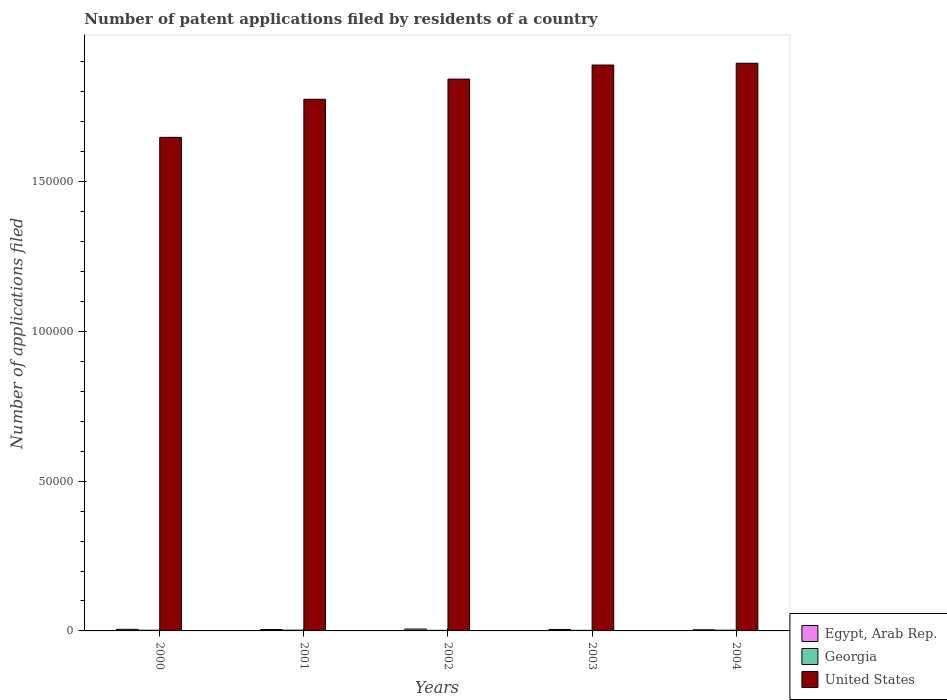How many different coloured bars are there?
Your answer should be very brief. 3. How many groups of bars are there?
Your answer should be very brief. 5. Are the number of bars on each tick of the X-axis equal?
Your answer should be very brief. Yes. What is the number of applications filed in Georgia in 2002?
Keep it short and to the point. 194. Across all years, what is the maximum number of applications filed in Georgia?
Offer a very short reply. 254. Across all years, what is the minimum number of applications filed in United States?
Keep it short and to the point. 1.65e+05. In which year was the number of applications filed in United States maximum?
Your answer should be very brief. 2004. In which year was the number of applications filed in Egypt, Arab Rep. minimum?
Provide a succinct answer. 2004. What is the total number of applications filed in United States in the graph?
Your answer should be compact. 9.05e+05. What is the difference between the number of applications filed in Egypt, Arab Rep. in 2003 and that in 2004?
Give a very brief answer. 111. What is the difference between the number of applications filed in Georgia in 2003 and the number of applications filed in Egypt, Arab Rep. in 2001?
Keep it short and to the point. -269. What is the average number of applications filed in United States per year?
Your response must be concise. 1.81e+05. In the year 2003, what is the difference between the number of applications filed in United States and number of applications filed in Georgia?
Offer a terse response. 1.89e+05. What is the ratio of the number of applications filed in Egypt, Arab Rep. in 2002 to that in 2004?
Keep it short and to the point. 1.64. Is the number of applications filed in Egypt, Arab Rep. in 2000 less than that in 2003?
Keep it short and to the point. No. What is the difference between the highest and the second highest number of applications filed in Egypt, Arab Rep.?
Your answer should be very brief. 93. What is the difference between the highest and the lowest number of applications filed in Egypt, Arab Rep.?
Your answer should be compact. 245. In how many years, is the number of applications filed in United States greater than the average number of applications filed in United States taken over all years?
Give a very brief answer. 3. What does the 3rd bar from the left in 2002 represents?
Your answer should be very brief. United States. Is it the case that in every year, the sum of the number of applications filed in Georgia and number of applications filed in United States is greater than the number of applications filed in Egypt, Arab Rep.?
Provide a succinct answer. Yes. Are all the bars in the graph horizontal?
Your answer should be compact. No. What is the difference between two consecutive major ticks on the Y-axis?
Keep it short and to the point. 5.00e+04. Are the values on the major ticks of Y-axis written in scientific E-notation?
Give a very brief answer. No. Where does the legend appear in the graph?
Keep it short and to the point. Bottom right. How many legend labels are there?
Make the answer very short. 3. What is the title of the graph?
Give a very brief answer. Number of patent applications filed by residents of a country. What is the label or title of the X-axis?
Offer a very short reply. Years. What is the label or title of the Y-axis?
Offer a terse response. Number of applications filed. What is the Number of applications filed in Egypt, Arab Rep. in 2000?
Give a very brief answer. 534. What is the Number of applications filed in Georgia in 2000?
Your answer should be compact. 232. What is the Number of applications filed in United States in 2000?
Your answer should be very brief. 1.65e+05. What is the Number of applications filed in Egypt, Arab Rep. in 2001?
Offer a very short reply. 464. What is the Number of applications filed in Georgia in 2001?
Give a very brief answer. 254. What is the Number of applications filed in United States in 2001?
Offer a terse response. 1.78e+05. What is the Number of applications filed of Egypt, Arab Rep. in 2002?
Your response must be concise. 627. What is the Number of applications filed in Georgia in 2002?
Your answer should be very brief. 194. What is the Number of applications filed in United States in 2002?
Your answer should be compact. 1.84e+05. What is the Number of applications filed of Egypt, Arab Rep. in 2003?
Keep it short and to the point. 493. What is the Number of applications filed of Georgia in 2003?
Give a very brief answer. 195. What is the Number of applications filed of United States in 2003?
Provide a succinct answer. 1.89e+05. What is the Number of applications filed of Egypt, Arab Rep. in 2004?
Your answer should be very brief. 382. What is the Number of applications filed in Georgia in 2004?
Make the answer very short. 249. What is the Number of applications filed of United States in 2004?
Make the answer very short. 1.90e+05. Across all years, what is the maximum Number of applications filed in Egypt, Arab Rep.?
Your answer should be very brief. 627. Across all years, what is the maximum Number of applications filed of Georgia?
Your answer should be compact. 254. Across all years, what is the maximum Number of applications filed in United States?
Your answer should be very brief. 1.90e+05. Across all years, what is the minimum Number of applications filed of Egypt, Arab Rep.?
Give a very brief answer. 382. Across all years, what is the minimum Number of applications filed of Georgia?
Provide a short and direct response. 194. Across all years, what is the minimum Number of applications filed in United States?
Offer a very short reply. 1.65e+05. What is the total Number of applications filed of Egypt, Arab Rep. in the graph?
Make the answer very short. 2500. What is the total Number of applications filed in Georgia in the graph?
Keep it short and to the point. 1124. What is the total Number of applications filed in United States in the graph?
Your answer should be very brief. 9.05e+05. What is the difference between the Number of applications filed of Egypt, Arab Rep. in 2000 and that in 2001?
Offer a terse response. 70. What is the difference between the Number of applications filed in Georgia in 2000 and that in 2001?
Offer a terse response. -22. What is the difference between the Number of applications filed of United States in 2000 and that in 2001?
Ensure brevity in your answer.  -1.27e+04. What is the difference between the Number of applications filed of Egypt, Arab Rep. in 2000 and that in 2002?
Offer a terse response. -93. What is the difference between the Number of applications filed in Georgia in 2000 and that in 2002?
Your answer should be very brief. 38. What is the difference between the Number of applications filed in United States in 2000 and that in 2002?
Provide a succinct answer. -1.94e+04. What is the difference between the Number of applications filed in Egypt, Arab Rep. in 2000 and that in 2003?
Keep it short and to the point. 41. What is the difference between the Number of applications filed of United States in 2000 and that in 2003?
Your answer should be compact. -2.41e+04. What is the difference between the Number of applications filed in Egypt, Arab Rep. in 2000 and that in 2004?
Your answer should be compact. 152. What is the difference between the Number of applications filed in United States in 2000 and that in 2004?
Make the answer very short. -2.47e+04. What is the difference between the Number of applications filed in Egypt, Arab Rep. in 2001 and that in 2002?
Your response must be concise. -163. What is the difference between the Number of applications filed of United States in 2001 and that in 2002?
Ensure brevity in your answer.  -6732. What is the difference between the Number of applications filed in United States in 2001 and that in 2003?
Offer a very short reply. -1.14e+04. What is the difference between the Number of applications filed of Egypt, Arab Rep. in 2001 and that in 2004?
Make the answer very short. 82. What is the difference between the Number of applications filed of Georgia in 2001 and that in 2004?
Provide a short and direct response. 5. What is the difference between the Number of applications filed of United States in 2001 and that in 2004?
Give a very brief answer. -1.20e+04. What is the difference between the Number of applications filed in Egypt, Arab Rep. in 2002 and that in 2003?
Ensure brevity in your answer.  134. What is the difference between the Number of applications filed in Georgia in 2002 and that in 2003?
Give a very brief answer. -1. What is the difference between the Number of applications filed of United States in 2002 and that in 2003?
Your answer should be very brief. -4696. What is the difference between the Number of applications filed of Egypt, Arab Rep. in 2002 and that in 2004?
Your answer should be compact. 245. What is the difference between the Number of applications filed of Georgia in 2002 and that in 2004?
Provide a short and direct response. -55. What is the difference between the Number of applications filed of United States in 2002 and that in 2004?
Make the answer very short. -5291. What is the difference between the Number of applications filed in Egypt, Arab Rep. in 2003 and that in 2004?
Ensure brevity in your answer.  111. What is the difference between the Number of applications filed in Georgia in 2003 and that in 2004?
Offer a very short reply. -54. What is the difference between the Number of applications filed of United States in 2003 and that in 2004?
Make the answer very short. -595. What is the difference between the Number of applications filed of Egypt, Arab Rep. in 2000 and the Number of applications filed of Georgia in 2001?
Provide a succinct answer. 280. What is the difference between the Number of applications filed of Egypt, Arab Rep. in 2000 and the Number of applications filed of United States in 2001?
Your answer should be very brief. -1.77e+05. What is the difference between the Number of applications filed of Georgia in 2000 and the Number of applications filed of United States in 2001?
Make the answer very short. -1.77e+05. What is the difference between the Number of applications filed of Egypt, Arab Rep. in 2000 and the Number of applications filed of Georgia in 2002?
Your answer should be compact. 340. What is the difference between the Number of applications filed in Egypt, Arab Rep. in 2000 and the Number of applications filed in United States in 2002?
Keep it short and to the point. -1.84e+05. What is the difference between the Number of applications filed in Georgia in 2000 and the Number of applications filed in United States in 2002?
Keep it short and to the point. -1.84e+05. What is the difference between the Number of applications filed of Egypt, Arab Rep. in 2000 and the Number of applications filed of Georgia in 2003?
Offer a terse response. 339. What is the difference between the Number of applications filed in Egypt, Arab Rep. in 2000 and the Number of applications filed in United States in 2003?
Your response must be concise. -1.88e+05. What is the difference between the Number of applications filed of Georgia in 2000 and the Number of applications filed of United States in 2003?
Provide a short and direct response. -1.89e+05. What is the difference between the Number of applications filed of Egypt, Arab Rep. in 2000 and the Number of applications filed of Georgia in 2004?
Provide a succinct answer. 285. What is the difference between the Number of applications filed of Egypt, Arab Rep. in 2000 and the Number of applications filed of United States in 2004?
Keep it short and to the point. -1.89e+05. What is the difference between the Number of applications filed in Georgia in 2000 and the Number of applications filed in United States in 2004?
Make the answer very short. -1.89e+05. What is the difference between the Number of applications filed of Egypt, Arab Rep. in 2001 and the Number of applications filed of Georgia in 2002?
Your answer should be compact. 270. What is the difference between the Number of applications filed of Egypt, Arab Rep. in 2001 and the Number of applications filed of United States in 2002?
Offer a very short reply. -1.84e+05. What is the difference between the Number of applications filed of Georgia in 2001 and the Number of applications filed of United States in 2002?
Offer a very short reply. -1.84e+05. What is the difference between the Number of applications filed of Egypt, Arab Rep. in 2001 and the Number of applications filed of Georgia in 2003?
Offer a very short reply. 269. What is the difference between the Number of applications filed in Egypt, Arab Rep. in 2001 and the Number of applications filed in United States in 2003?
Give a very brief answer. -1.88e+05. What is the difference between the Number of applications filed of Georgia in 2001 and the Number of applications filed of United States in 2003?
Your answer should be very brief. -1.89e+05. What is the difference between the Number of applications filed of Egypt, Arab Rep. in 2001 and the Number of applications filed of Georgia in 2004?
Your response must be concise. 215. What is the difference between the Number of applications filed of Egypt, Arab Rep. in 2001 and the Number of applications filed of United States in 2004?
Offer a terse response. -1.89e+05. What is the difference between the Number of applications filed in Georgia in 2001 and the Number of applications filed in United States in 2004?
Give a very brief answer. -1.89e+05. What is the difference between the Number of applications filed in Egypt, Arab Rep. in 2002 and the Number of applications filed in Georgia in 2003?
Offer a terse response. 432. What is the difference between the Number of applications filed of Egypt, Arab Rep. in 2002 and the Number of applications filed of United States in 2003?
Your answer should be very brief. -1.88e+05. What is the difference between the Number of applications filed of Georgia in 2002 and the Number of applications filed of United States in 2003?
Offer a terse response. -1.89e+05. What is the difference between the Number of applications filed of Egypt, Arab Rep. in 2002 and the Number of applications filed of Georgia in 2004?
Your answer should be very brief. 378. What is the difference between the Number of applications filed of Egypt, Arab Rep. in 2002 and the Number of applications filed of United States in 2004?
Provide a short and direct response. -1.89e+05. What is the difference between the Number of applications filed of Georgia in 2002 and the Number of applications filed of United States in 2004?
Your response must be concise. -1.89e+05. What is the difference between the Number of applications filed of Egypt, Arab Rep. in 2003 and the Number of applications filed of Georgia in 2004?
Ensure brevity in your answer.  244. What is the difference between the Number of applications filed in Egypt, Arab Rep. in 2003 and the Number of applications filed in United States in 2004?
Ensure brevity in your answer.  -1.89e+05. What is the difference between the Number of applications filed in Georgia in 2003 and the Number of applications filed in United States in 2004?
Provide a short and direct response. -1.89e+05. What is the average Number of applications filed in Egypt, Arab Rep. per year?
Ensure brevity in your answer.  500. What is the average Number of applications filed of Georgia per year?
Your response must be concise. 224.8. What is the average Number of applications filed of United States per year?
Your response must be concise. 1.81e+05. In the year 2000, what is the difference between the Number of applications filed in Egypt, Arab Rep. and Number of applications filed in Georgia?
Ensure brevity in your answer.  302. In the year 2000, what is the difference between the Number of applications filed in Egypt, Arab Rep. and Number of applications filed in United States?
Your answer should be very brief. -1.64e+05. In the year 2000, what is the difference between the Number of applications filed of Georgia and Number of applications filed of United States?
Your answer should be very brief. -1.65e+05. In the year 2001, what is the difference between the Number of applications filed in Egypt, Arab Rep. and Number of applications filed in Georgia?
Make the answer very short. 210. In the year 2001, what is the difference between the Number of applications filed of Egypt, Arab Rep. and Number of applications filed of United States?
Give a very brief answer. -1.77e+05. In the year 2001, what is the difference between the Number of applications filed in Georgia and Number of applications filed in United States?
Offer a very short reply. -1.77e+05. In the year 2002, what is the difference between the Number of applications filed of Egypt, Arab Rep. and Number of applications filed of Georgia?
Provide a succinct answer. 433. In the year 2002, what is the difference between the Number of applications filed in Egypt, Arab Rep. and Number of applications filed in United States?
Your response must be concise. -1.84e+05. In the year 2002, what is the difference between the Number of applications filed of Georgia and Number of applications filed of United States?
Your answer should be compact. -1.84e+05. In the year 2003, what is the difference between the Number of applications filed of Egypt, Arab Rep. and Number of applications filed of Georgia?
Your answer should be very brief. 298. In the year 2003, what is the difference between the Number of applications filed of Egypt, Arab Rep. and Number of applications filed of United States?
Make the answer very short. -1.88e+05. In the year 2003, what is the difference between the Number of applications filed in Georgia and Number of applications filed in United States?
Ensure brevity in your answer.  -1.89e+05. In the year 2004, what is the difference between the Number of applications filed in Egypt, Arab Rep. and Number of applications filed in Georgia?
Ensure brevity in your answer.  133. In the year 2004, what is the difference between the Number of applications filed of Egypt, Arab Rep. and Number of applications filed of United States?
Offer a terse response. -1.89e+05. In the year 2004, what is the difference between the Number of applications filed of Georgia and Number of applications filed of United States?
Provide a short and direct response. -1.89e+05. What is the ratio of the Number of applications filed in Egypt, Arab Rep. in 2000 to that in 2001?
Your response must be concise. 1.15. What is the ratio of the Number of applications filed in Georgia in 2000 to that in 2001?
Ensure brevity in your answer.  0.91. What is the ratio of the Number of applications filed in United States in 2000 to that in 2001?
Keep it short and to the point. 0.93. What is the ratio of the Number of applications filed of Egypt, Arab Rep. in 2000 to that in 2002?
Ensure brevity in your answer.  0.85. What is the ratio of the Number of applications filed of Georgia in 2000 to that in 2002?
Your response must be concise. 1.2. What is the ratio of the Number of applications filed in United States in 2000 to that in 2002?
Your answer should be very brief. 0.89. What is the ratio of the Number of applications filed in Egypt, Arab Rep. in 2000 to that in 2003?
Offer a terse response. 1.08. What is the ratio of the Number of applications filed of Georgia in 2000 to that in 2003?
Make the answer very short. 1.19. What is the ratio of the Number of applications filed of United States in 2000 to that in 2003?
Offer a terse response. 0.87. What is the ratio of the Number of applications filed in Egypt, Arab Rep. in 2000 to that in 2004?
Ensure brevity in your answer.  1.4. What is the ratio of the Number of applications filed of Georgia in 2000 to that in 2004?
Keep it short and to the point. 0.93. What is the ratio of the Number of applications filed in United States in 2000 to that in 2004?
Give a very brief answer. 0.87. What is the ratio of the Number of applications filed in Egypt, Arab Rep. in 2001 to that in 2002?
Provide a succinct answer. 0.74. What is the ratio of the Number of applications filed in Georgia in 2001 to that in 2002?
Provide a short and direct response. 1.31. What is the ratio of the Number of applications filed of United States in 2001 to that in 2002?
Offer a very short reply. 0.96. What is the ratio of the Number of applications filed in Georgia in 2001 to that in 2003?
Your answer should be very brief. 1.3. What is the ratio of the Number of applications filed in United States in 2001 to that in 2003?
Your response must be concise. 0.94. What is the ratio of the Number of applications filed of Egypt, Arab Rep. in 2001 to that in 2004?
Your answer should be very brief. 1.21. What is the ratio of the Number of applications filed in Georgia in 2001 to that in 2004?
Provide a short and direct response. 1.02. What is the ratio of the Number of applications filed of United States in 2001 to that in 2004?
Ensure brevity in your answer.  0.94. What is the ratio of the Number of applications filed of Egypt, Arab Rep. in 2002 to that in 2003?
Ensure brevity in your answer.  1.27. What is the ratio of the Number of applications filed in Georgia in 2002 to that in 2003?
Provide a short and direct response. 0.99. What is the ratio of the Number of applications filed in United States in 2002 to that in 2003?
Keep it short and to the point. 0.98. What is the ratio of the Number of applications filed in Egypt, Arab Rep. in 2002 to that in 2004?
Provide a short and direct response. 1.64. What is the ratio of the Number of applications filed of Georgia in 2002 to that in 2004?
Your answer should be compact. 0.78. What is the ratio of the Number of applications filed in United States in 2002 to that in 2004?
Your response must be concise. 0.97. What is the ratio of the Number of applications filed in Egypt, Arab Rep. in 2003 to that in 2004?
Offer a terse response. 1.29. What is the ratio of the Number of applications filed in Georgia in 2003 to that in 2004?
Offer a very short reply. 0.78. What is the ratio of the Number of applications filed in United States in 2003 to that in 2004?
Make the answer very short. 1. What is the difference between the highest and the second highest Number of applications filed of Egypt, Arab Rep.?
Offer a terse response. 93. What is the difference between the highest and the second highest Number of applications filed of United States?
Your answer should be compact. 595. What is the difference between the highest and the lowest Number of applications filed in Egypt, Arab Rep.?
Offer a very short reply. 245. What is the difference between the highest and the lowest Number of applications filed of United States?
Give a very brief answer. 2.47e+04. 